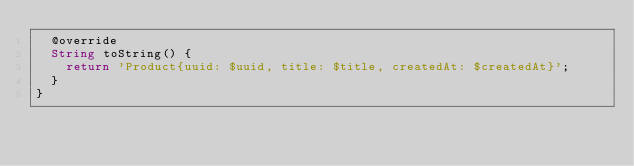Convert code to text. <code><loc_0><loc_0><loc_500><loc_500><_Dart_>  @override
  String toString() {
    return 'Product{uuid: $uuid, title: $title, createdAt: $createdAt}';
  }
}
</code> 